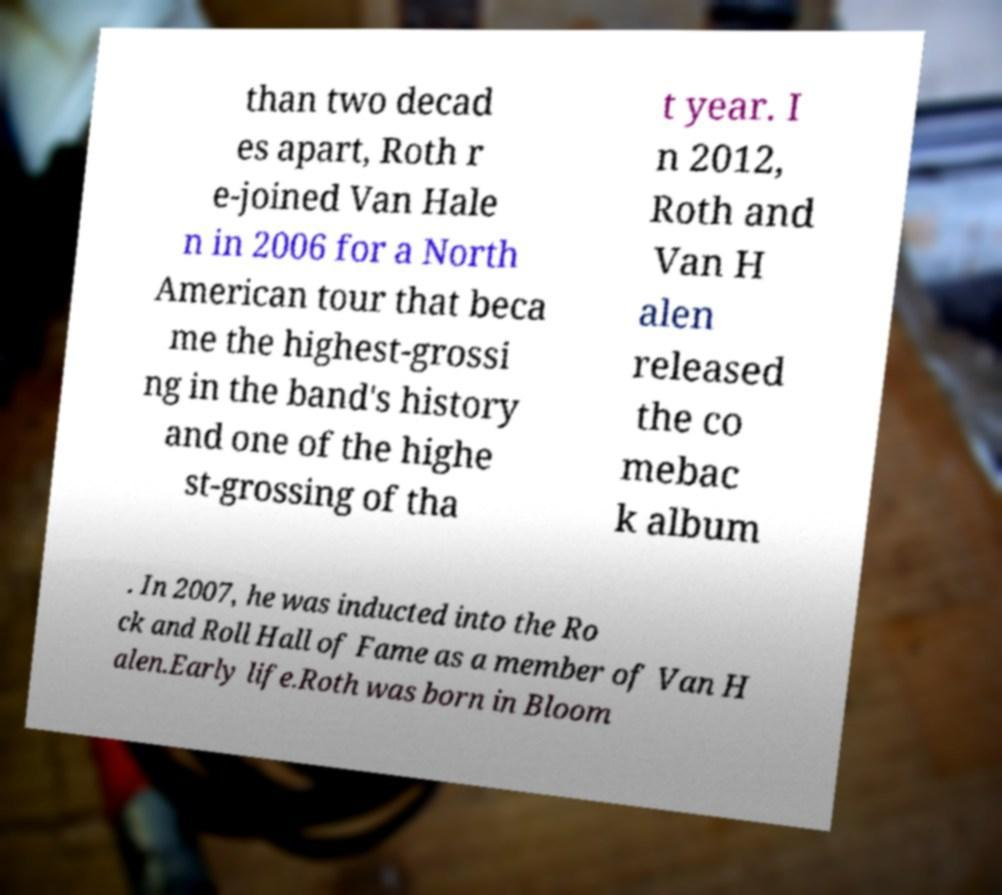Please read and relay the text visible in this image. What does it say? than two decad es apart, Roth r e-joined Van Hale n in 2006 for a North American tour that beca me the highest-grossi ng in the band's history and one of the highe st-grossing of tha t year. I n 2012, Roth and Van H alen released the co mebac k album . In 2007, he was inducted into the Ro ck and Roll Hall of Fame as a member of Van H alen.Early life.Roth was born in Bloom 